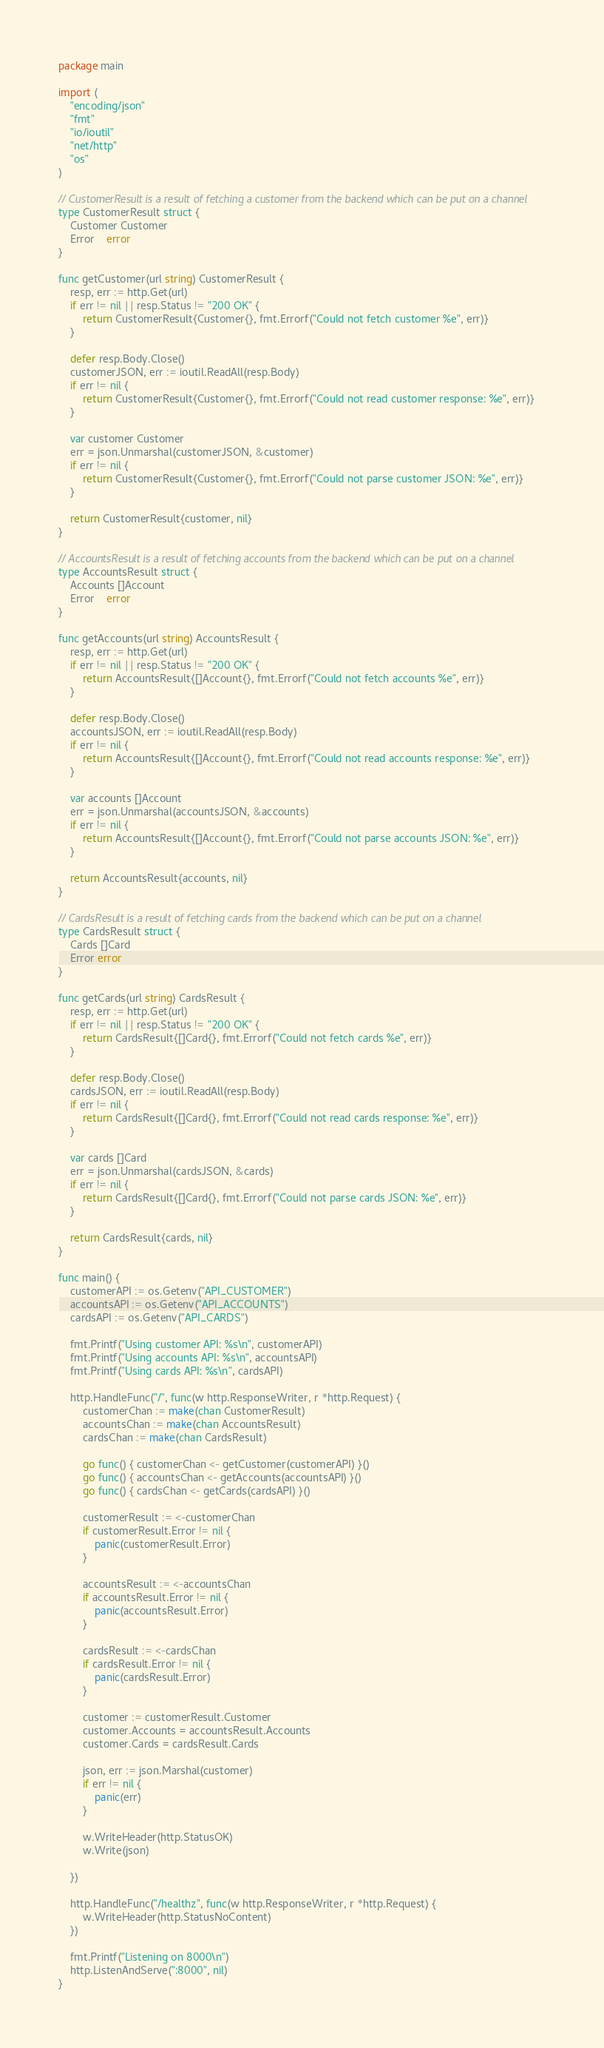<code> <loc_0><loc_0><loc_500><loc_500><_Go_>package main

import (
	"encoding/json"
	"fmt"
	"io/ioutil"
	"net/http"
	"os"
)

// CustomerResult is a result of fetching a customer from the backend which can be put on a channel
type CustomerResult struct {
	Customer Customer
	Error    error
}

func getCustomer(url string) CustomerResult {
	resp, err := http.Get(url)
	if err != nil || resp.Status != "200 OK" {
		return CustomerResult{Customer{}, fmt.Errorf("Could not fetch customer %e", err)}
	}

	defer resp.Body.Close()
	customerJSON, err := ioutil.ReadAll(resp.Body)
	if err != nil {
		return CustomerResult{Customer{}, fmt.Errorf("Could not read customer response: %e", err)}
	}

	var customer Customer
	err = json.Unmarshal(customerJSON, &customer)
	if err != nil {
		return CustomerResult{Customer{}, fmt.Errorf("Could not parse customer JSON: %e", err)}
	}

	return CustomerResult{customer, nil}
}

// AccountsResult is a result of fetching accounts from the backend which can be put on a channel
type AccountsResult struct {
	Accounts []Account
	Error    error
}

func getAccounts(url string) AccountsResult {
	resp, err := http.Get(url)
	if err != nil || resp.Status != "200 OK" {
		return AccountsResult{[]Account{}, fmt.Errorf("Could not fetch accounts %e", err)}
	}

	defer resp.Body.Close()
	accountsJSON, err := ioutil.ReadAll(resp.Body)
	if err != nil {
		return AccountsResult{[]Account{}, fmt.Errorf("Could not read accounts response: %e", err)}
	}

	var accounts []Account
	err = json.Unmarshal(accountsJSON, &accounts)
	if err != nil {
		return AccountsResult{[]Account{}, fmt.Errorf("Could not parse accounts JSON: %e", err)}
	}

	return AccountsResult{accounts, nil}
}

// CardsResult is a result of fetching cards from the backend which can be put on a channel
type CardsResult struct {
	Cards []Card
	Error error
}

func getCards(url string) CardsResult {
	resp, err := http.Get(url)
	if err != nil || resp.Status != "200 OK" {
		return CardsResult{[]Card{}, fmt.Errorf("Could not fetch cards %e", err)}
	}

	defer resp.Body.Close()
	cardsJSON, err := ioutil.ReadAll(resp.Body)
	if err != nil {
		return CardsResult{[]Card{}, fmt.Errorf("Could not read cards response: %e", err)}
	}

	var cards []Card
	err = json.Unmarshal(cardsJSON, &cards)
	if err != nil {
		return CardsResult{[]Card{}, fmt.Errorf("Could not parse cards JSON: %e", err)}
	}

	return CardsResult{cards, nil}
}

func main() {
	customerAPI := os.Getenv("API_CUSTOMER")
	accountsAPI := os.Getenv("API_ACCOUNTS")
	cardsAPI := os.Getenv("API_CARDS")

	fmt.Printf("Using customer API: %s\n", customerAPI)
	fmt.Printf("Using accounts API: %s\n", accountsAPI)
	fmt.Printf("Using cards API: %s\n", cardsAPI)

	http.HandleFunc("/", func(w http.ResponseWriter, r *http.Request) {
		customerChan := make(chan CustomerResult)
		accountsChan := make(chan AccountsResult)
		cardsChan := make(chan CardsResult)

		go func() { customerChan <- getCustomer(customerAPI) }()
		go func() { accountsChan <- getAccounts(accountsAPI) }()
		go func() { cardsChan <- getCards(cardsAPI) }()

		customerResult := <-customerChan
		if customerResult.Error != nil {
			panic(customerResult.Error)
		}

		accountsResult := <-accountsChan
		if accountsResult.Error != nil {
			panic(accountsResult.Error)
		}

		cardsResult := <-cardsChan
		if cardsResult.Error != nil {
			panic(cardsResult.Error)
		}

		customer := customerResult.Customer
		customer.Accounts = accountsResult.Accounts
		customer.Cards = cardsResult.Cards

		json, err := json.Marshal(customer)
		if err != nil {
			panic(err)
		}

		w.WriteHeader(http.StatusOK)
		w.Write(json)

	})

	http.HandleFunc("/healthz", func(w http.ResponseWriter, r *http.Request) {
		w.WriteHeader(http.StatusNoContent)
	})

	fmt.Printf("Listening on 8000\n")
	http.ListenAndServe(":8000", nil)
}
</code> 